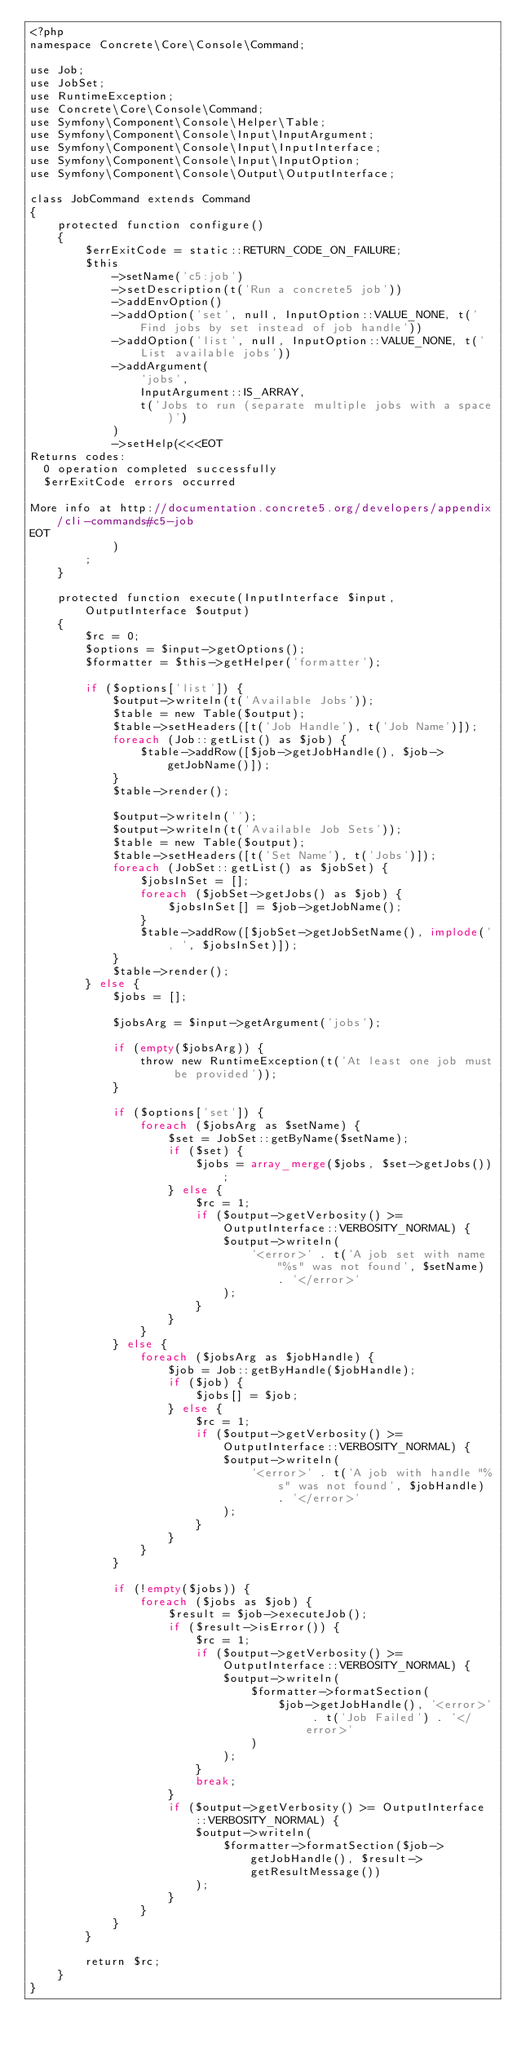<code> <loc_0><loc_0><loc_500><loc_500><_PHP_><?php
namespace Concrete\Core\Console\Command;

use Job;
use JobSet;
use RuntimeException;
use Concrete\Core\Console\Command;
use Symfony\Component\Console\Helper\Table;
use Symfony\Component\Console\Input\InputArgument;
use Symfony\Component\Console\Input\InputInterface;
use Symfony\Component\Console\Input\InputOption;
use Symfony\Component\Console\Output\OutputInterface;

class JobCommand extends Command
{
    protected function configure()
    {
        $errExitCode = static::RETURN_CODE_ON_FAILURE;
        $this
            ->setName('c5:job')
            ->setDescription(t('Run a concrete5 job'))
            ->addEnvOption()
            ->addOption('set', null, InputOption::VALUE_NONE, t('Find jobs by set instead of job handle'))
            ->addOption('list', null, InputOption::VALUE_NONE, t('List available jobs'))
            ->addArgument(
                'jobs',
                InputArgument::IS_ARRAY,
                t('Jobs to run (separate multiple jobs with a space)')
            )
            ->setHelp(<<<EOT
Returns codes:
  0 operation completed successfully
  $errExitCode errors occurred

More info at http://documentation.concrete5.org/developers/appendix/cli-commands#c5-job
EOT
            )
        ;
    }

    protected function execute(InputInterface $input, OutputInterface $output)
    {
        $rc = 0;
        $options = $input->getOptions();
        $formatter = $this->getHelper('formatter');

        if ($options['list']) {
            $output->writeln(t('Available Jobs'));
            $table = new Table($output);
            $table->setHeaders([t('Job Handle'), t('Job Name')]);
            foreach (Job::getList() as $job) {
                $table->addRow([$job->getJobHandle(), $job->getJobName()]);
            }
            $table->render();

            $output->writeln('');
            $output->writeln(t('Available Job Sets'));
            $table = new Table($output);
            $table->setHeaders([t('Set Name'), t('Jobs')]);
            foreach (JobSet::getList() as $jobSet) {
                $jobsInSet = [];
                foreach ($jobSet->getJobs() as $job) {
                    $jobsInSet[] = $job->getJobName();
                }
                $table->addRow([$jobSet->getJobSetName(), implode(', ', $jobsInSet)]);
            }
            $table->render();
        } else {
            $jobs = [];

            $jobsArg = $input->getArgument('jobs');

            if (empty($jobsArg)) {
                throw new RuntimeException(t('At least one job must be provided'));
            }

            if ($options['set']) {
                foreach ($jobsArg as $setName) {
                    $set = JobSet::getByName($setName);
                    if ($set) {
                        $jobs = array_merge($jobs, $set->getJobs());
                    } else {
                        $rc = 1;
                        if ($output->getVerbosity() >= OutputInterface::VERBOSITY_NORMAL) {
                            $output->writeln(
                                '<error>' . t('A job set with name "%s" was not found', $setName) . '</error>'
                            );
                        }
                    }
                }
            } else {
                foreach ($jobsArg as $jobHandle) {
                    $job = Job::getByHandle($jobHandle);
                    if ($job) {
                        $jobs[] = $job;
                    } else {
                        $rc = 1;
                        if ($output->getVerbosity() >= OutputInterface::VERBOSITY_NORMAL) {
                            $output->writeln(
                                '<error>' . t('A job with handle "%s" was not found', $jobHandle) . '</error>'
                            );
                        }
                    }
                }
            }

            if (!empty($jobs)) {
                foreach ($jobs as $job) {
                    $result = $job->executeJob();
                    if ($result->isError()) {
                        $rc = 1;
                        if ($output->getVerbosity() >= OutputInterface::VERBOSITY_NORMAL) {
                            $output->writeln(
                                $formatter->formatSection(
                                    $job->getJobHandle(), '<error>' . t('Job Failed') . '</error>'
                                )
                            );
                        }
                        break;
                    }
                    if ($output->getVerbosity() >= OutputInterface::VERBOSITY_NORMAL) {
                        $output->writeln(
                            $formatter->formatSection($job->getJobHandle(), $result->getResultMessage())
                        );
                    }
                }
            }
        }

        return $rc;
    }
}
</code> 